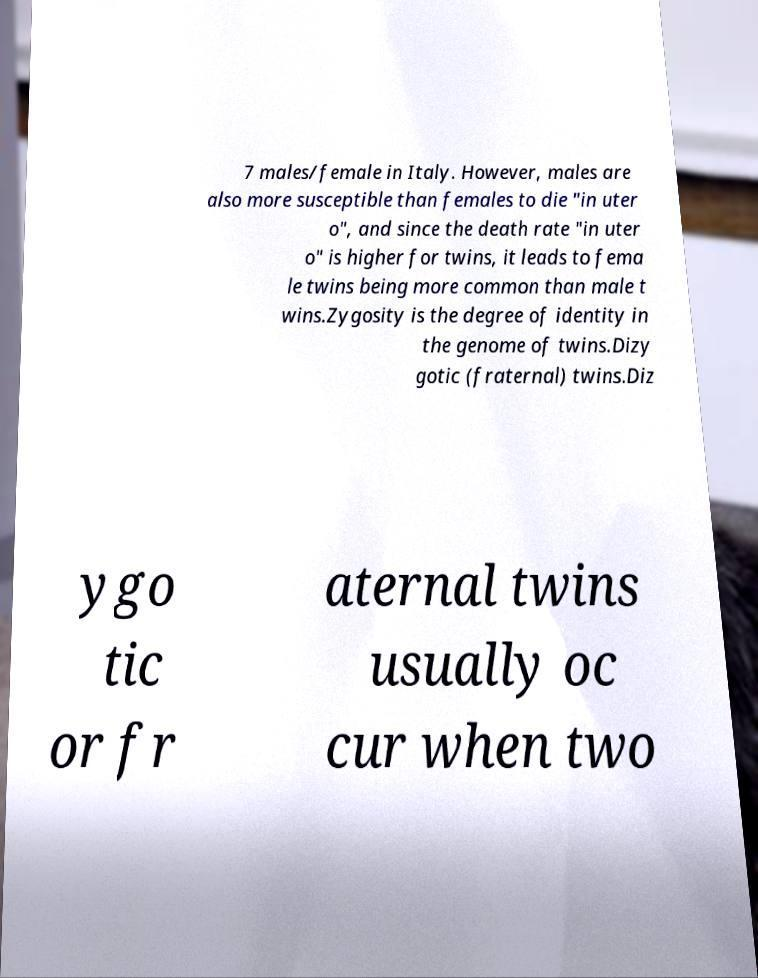Can you accurately transcribe the text from the provided image for me? 7 males/female in Italy. However, males are also more susceptible than females to die "in uter o", and since the death rate "in uter o" is higher for twins, it leads to fema le twins being more common than male t wins.Zygosity is the degree of identity in the genome of twins.Dizy gotic (fraternal) twins.Diz ygo tic or fr aternal twins usually oc cur when two 